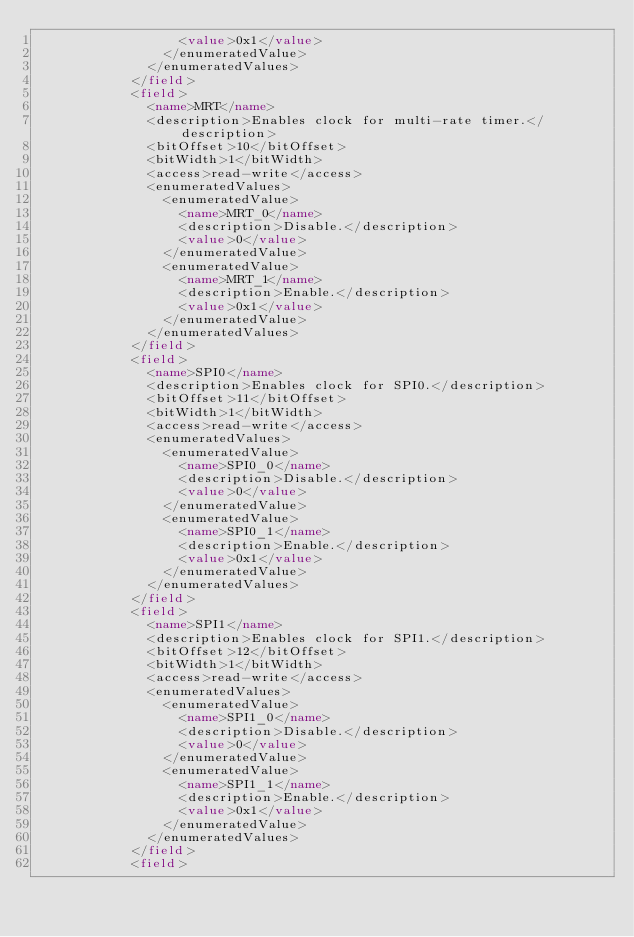Convert code to text. <code><loc_0><loc_0><loc_500><loc_500><_XML_>                  <value>0x1</value>
                </enumeratedValue>
              </enumeratedValues>
            </field>
            <field>
              <name>MRT</name>
              <description>Enables clock for multi-rate timer.</description>
              <bitOffset>10</bitOffset>
              <bitWidth>1</bitWidth>
              <access>read-write</access>
              <enumeratedValues>
                <enumeratedValue>
                  <name>MRT_0</name>
                  <description>Disable.</description>
                  <value>0</value>
                </enumeratedValue>
                <enumeratedValue>
                  <name>MRT_1</name>
                  <description>Enable.</description>
                  <value>0x1</value>
                </enumeratedValue>
              </enumeratedValues>
            </field>
            <field>
              <name>SPI0</name>
              <description>Enables clock for SPI0.</description>
              <bitOffset>11</bitOffset>
              <bitWidth>1</bitWidth>
              <access>read-write</access>
              <enumeratedValues>
                <enumeratedValue>
                  <name>SPI0_0</name>
                  <description>Disable.</description>
                  <value>0</value>
                </enumeratedValue>
                <enumeratedValue>
                  <name>SPI0_1</name>
                  <description>Enable.</description>
                  <value>0x1</value>
                </enumeratedValue>
              </enumeratedValues>
            </field>
            <field>
              <name>SPI1</name>
              <description>Enables clock for SPI1.</description>
              <bitOffset>12</bitOffset>
              <bitWidth>1</bitWidth>
              <access>read-write</access>
              <enumeratedValues>
                <enumeratedValue>
                  <name>SPI1_0</name>
                  <description>Disable.</description>
                  <value>0</value>
                </enumeratedValue>
                <enumeratedValue>
                  <name>SPI1_1</name>
                  <description>Enable.</description>
                  <value>0x1</value>
                </enumeratedValue>
              </enumeratedValues>
            </field>
            <field></code> 